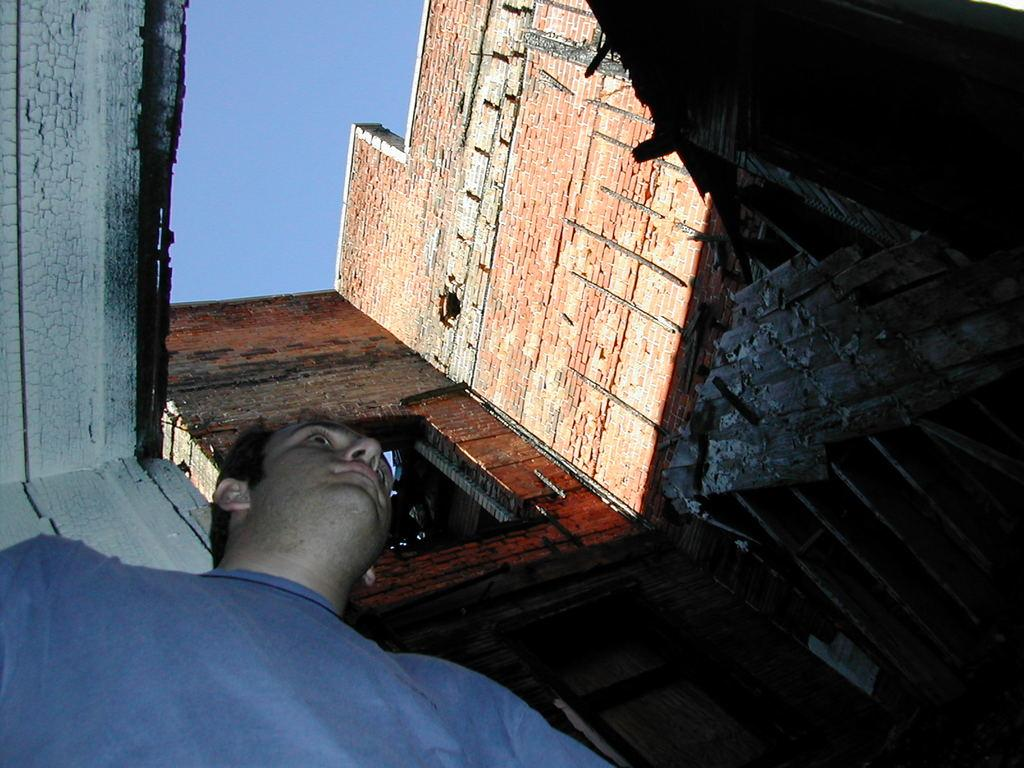What is the main structure in the picture? There is a building in the picture. Can you describe the person in the picture? There is a person with a blue t-shirt in the left bottom of the picture. What can be seen in the background of the picture? The sky is visible at the top of the picture. How many robins are perched on the net in the picture? There are no robins or nets present in the picture. What is the person's financial situation in the picture? There is no information about the person's financial situation in the picture. 